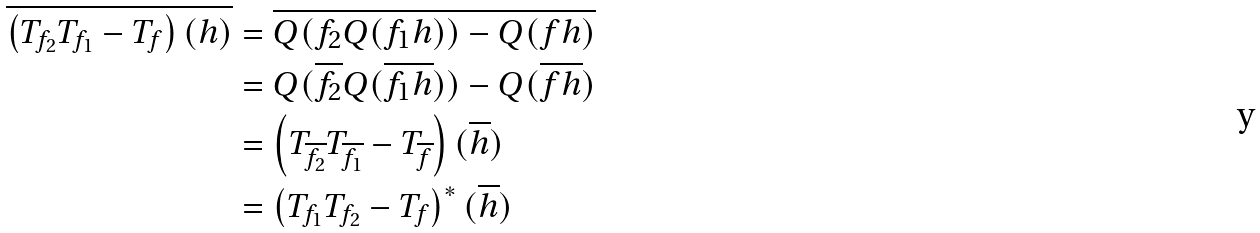Convert formula to latex. <formula><loc_0><loc_0><loc_500><loc_500>\overline { \left ( T _ { f _ { 2 } } T _ { f _ { 1 } } - T _ { f } \right ) ( h ) } & = \overline { Q ( f _ { 2 } Q ( f _ { 1 } h ) ) - Q ( f h ) } \\ & = Q ( \overline { f _ { 2 } } Q ( \overline { f _ { 1 } } \overline { h } ) ) - Q ( \overline { f } \overline { h } ) \\ & = \left ( T _ { \overline { f _ { 2 } } } T _ { \overline { f _ { 1 } } } - T _ { \overline { f } } \right ) ( \overline { h } ) \\ & = \left ( T _ { f _ { 1 } } T _ { f _ { 2 } } - T _ { f } \right ) ^ { * } ( \overline { h } )</formula> 